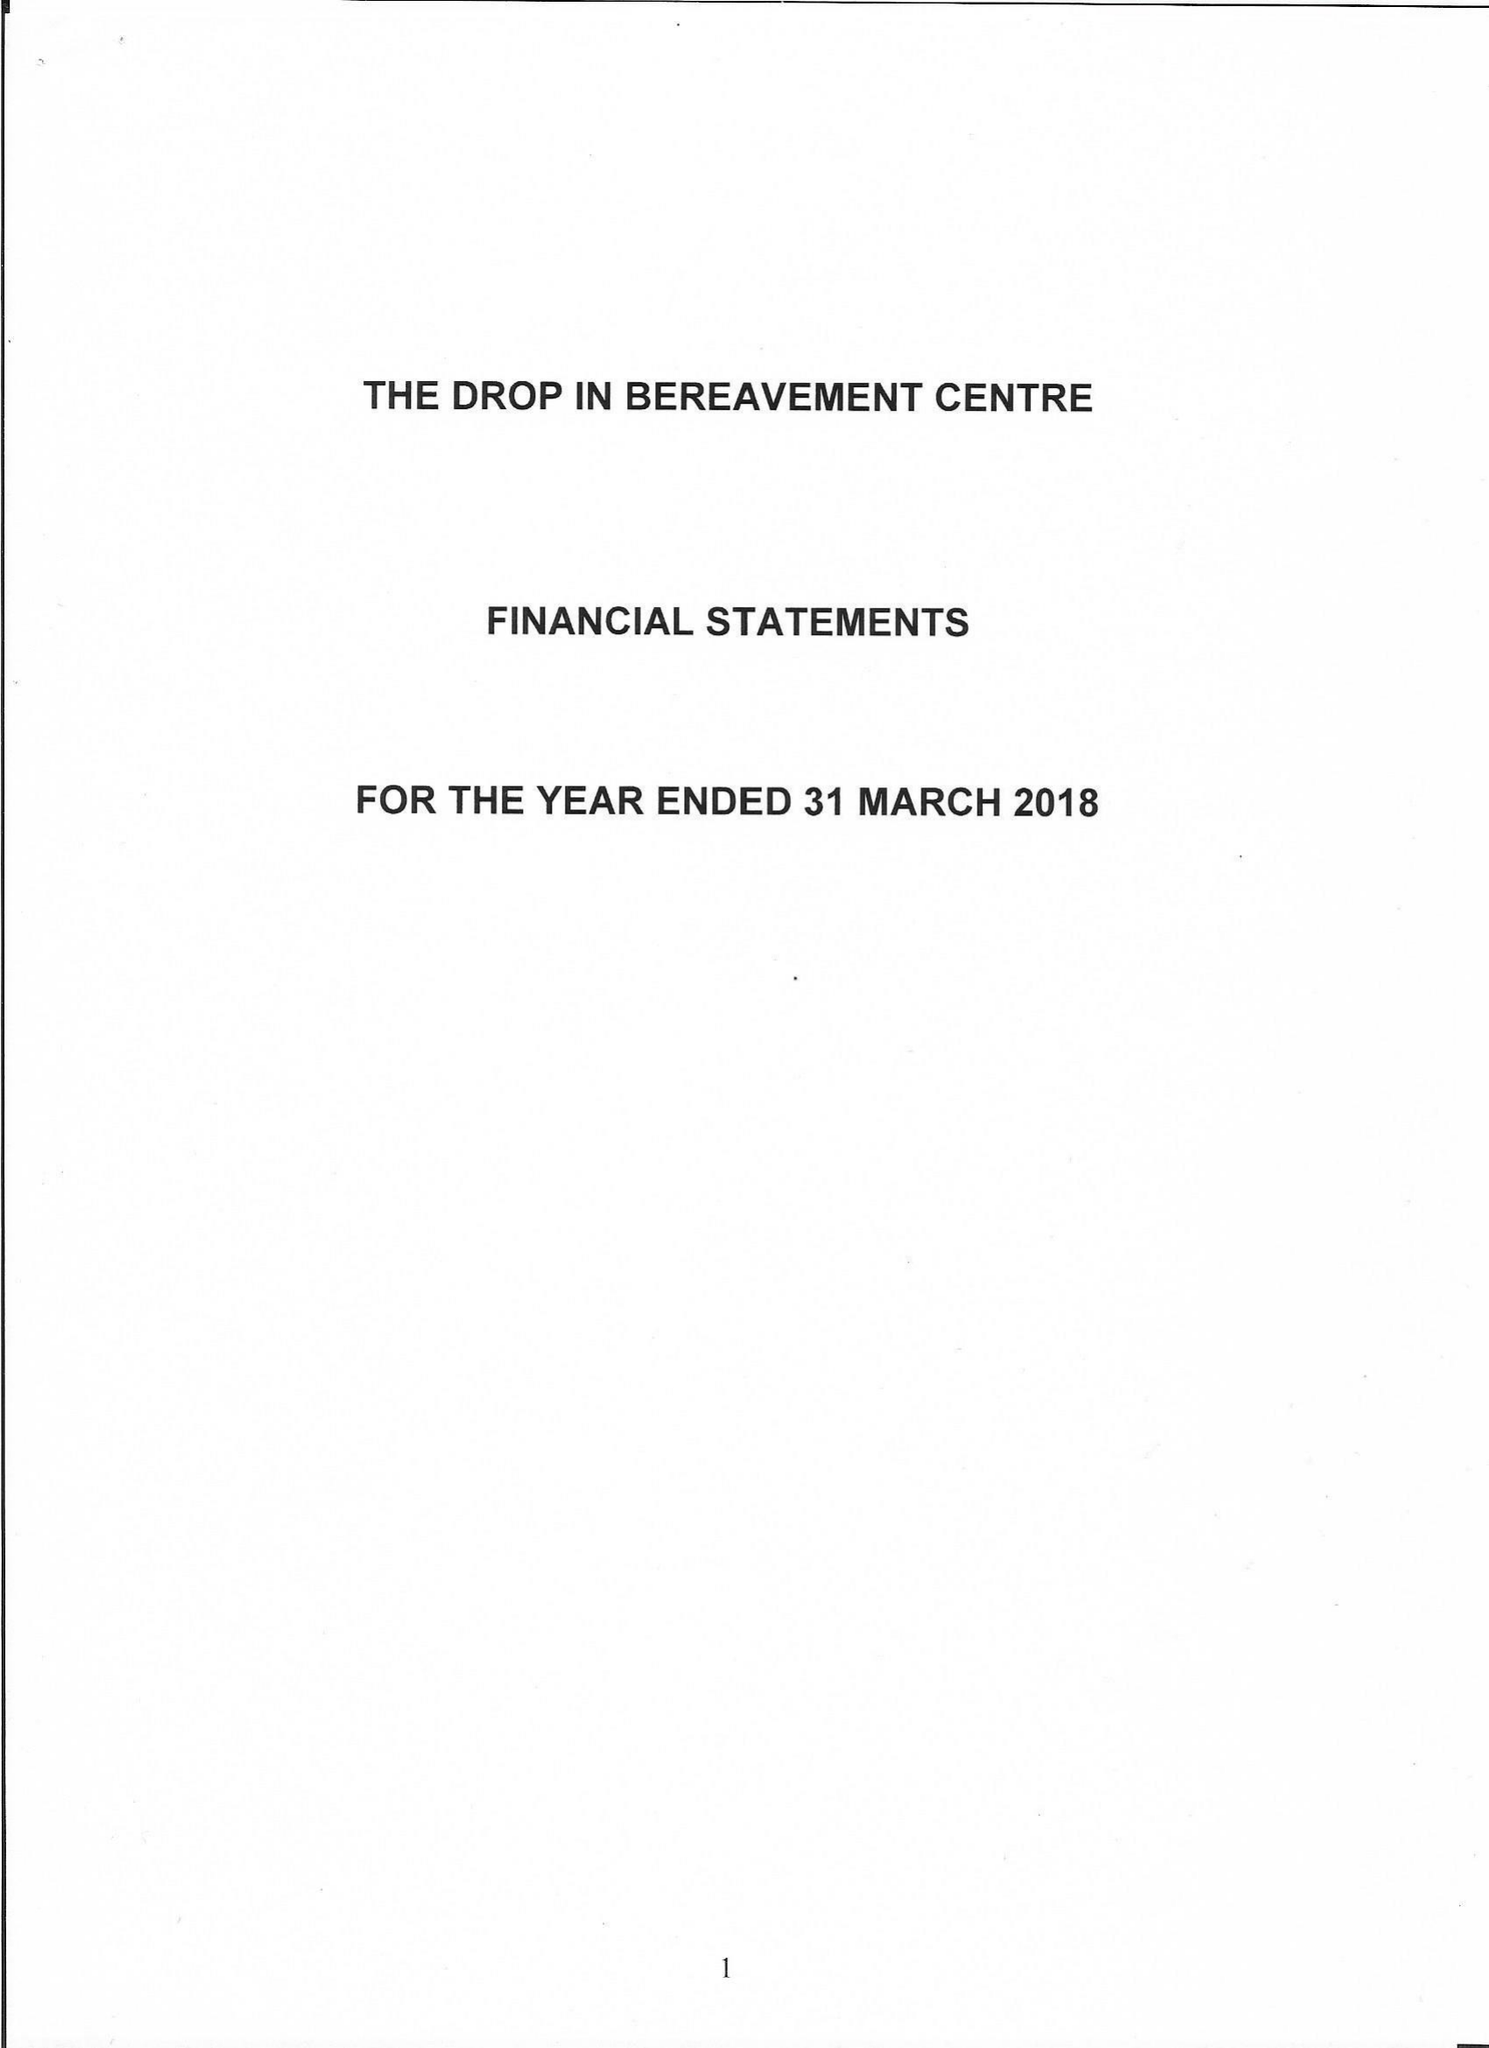What is the value for the address__street_line?
Answer the question using a single word or phrase. 187 GRANGE ROAD 